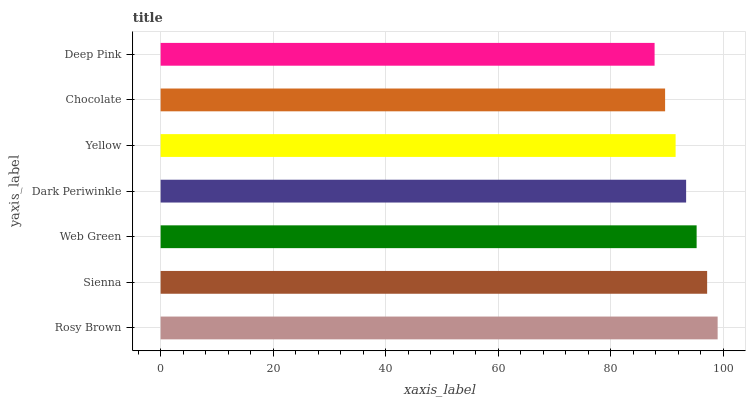Is Deep Pink the minimum?
Answer yes or no. Yes. Is Rosy Brown the maximum?
Answer yes or no. Yes. Is Sienna the minimum?
Answer yes or no. No. Is Sienna the maximum?
Answer yes or no. No. Is Rosy Brown greater than Sienna?
Answer yes or no. Yes. Is Sienna less than Rosy Brown?
Answer yes or no. Yes. Is Sienna greater than Rosy Brown?
Answer yes or no. No. Is Rosy Brown less than Sienna?
Answer yes or no. No. Is Dark Periwinkle the high median?
Answer yes or no. Yes. Is Dark Periwinkle the low median?
Answer yes or no. Yes. Is Web Green the high median?
Answer yes or no. No. Is Rosy Brown the low median?
Answer yes or no. No. 